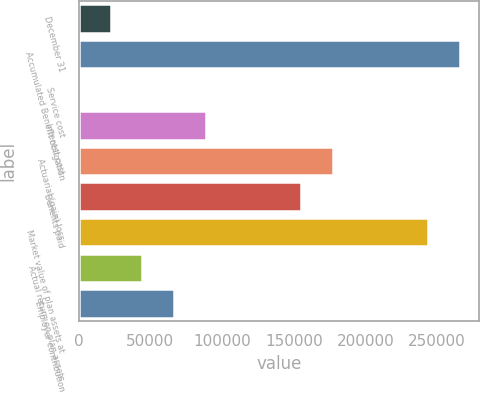Convert chart to OTSL. <chart><loc_0><loc_0><loc_500><loc_500><bar_chart><fcel>December 31<fcel>Accumulated Benefit obligation<fcel>Service cost<fcel>Interest cost<fcel>Actuarial (gain) loss<fcel>Benefits paid<fcel>Market value of plan assets at<fcel>Actual return on plan assets<fcel>Employer contribution<nl><fcel>22249.5<fcel>266048<fcel>86<fcel>88740<fcel>177394<fcel>155230<fcel>243884<fcel>44413<fcel>66576.5<nl></chart> 